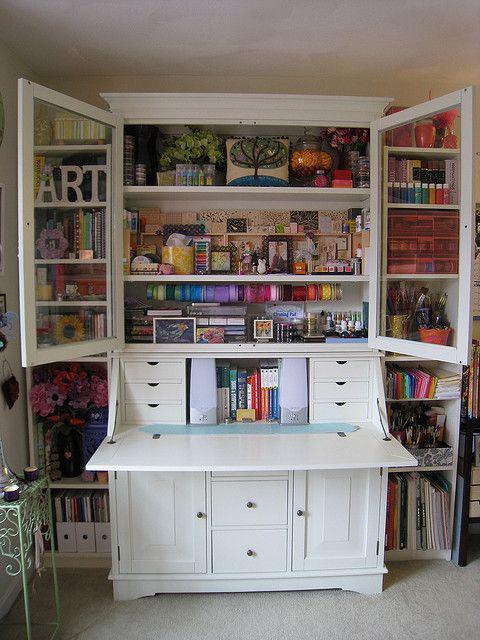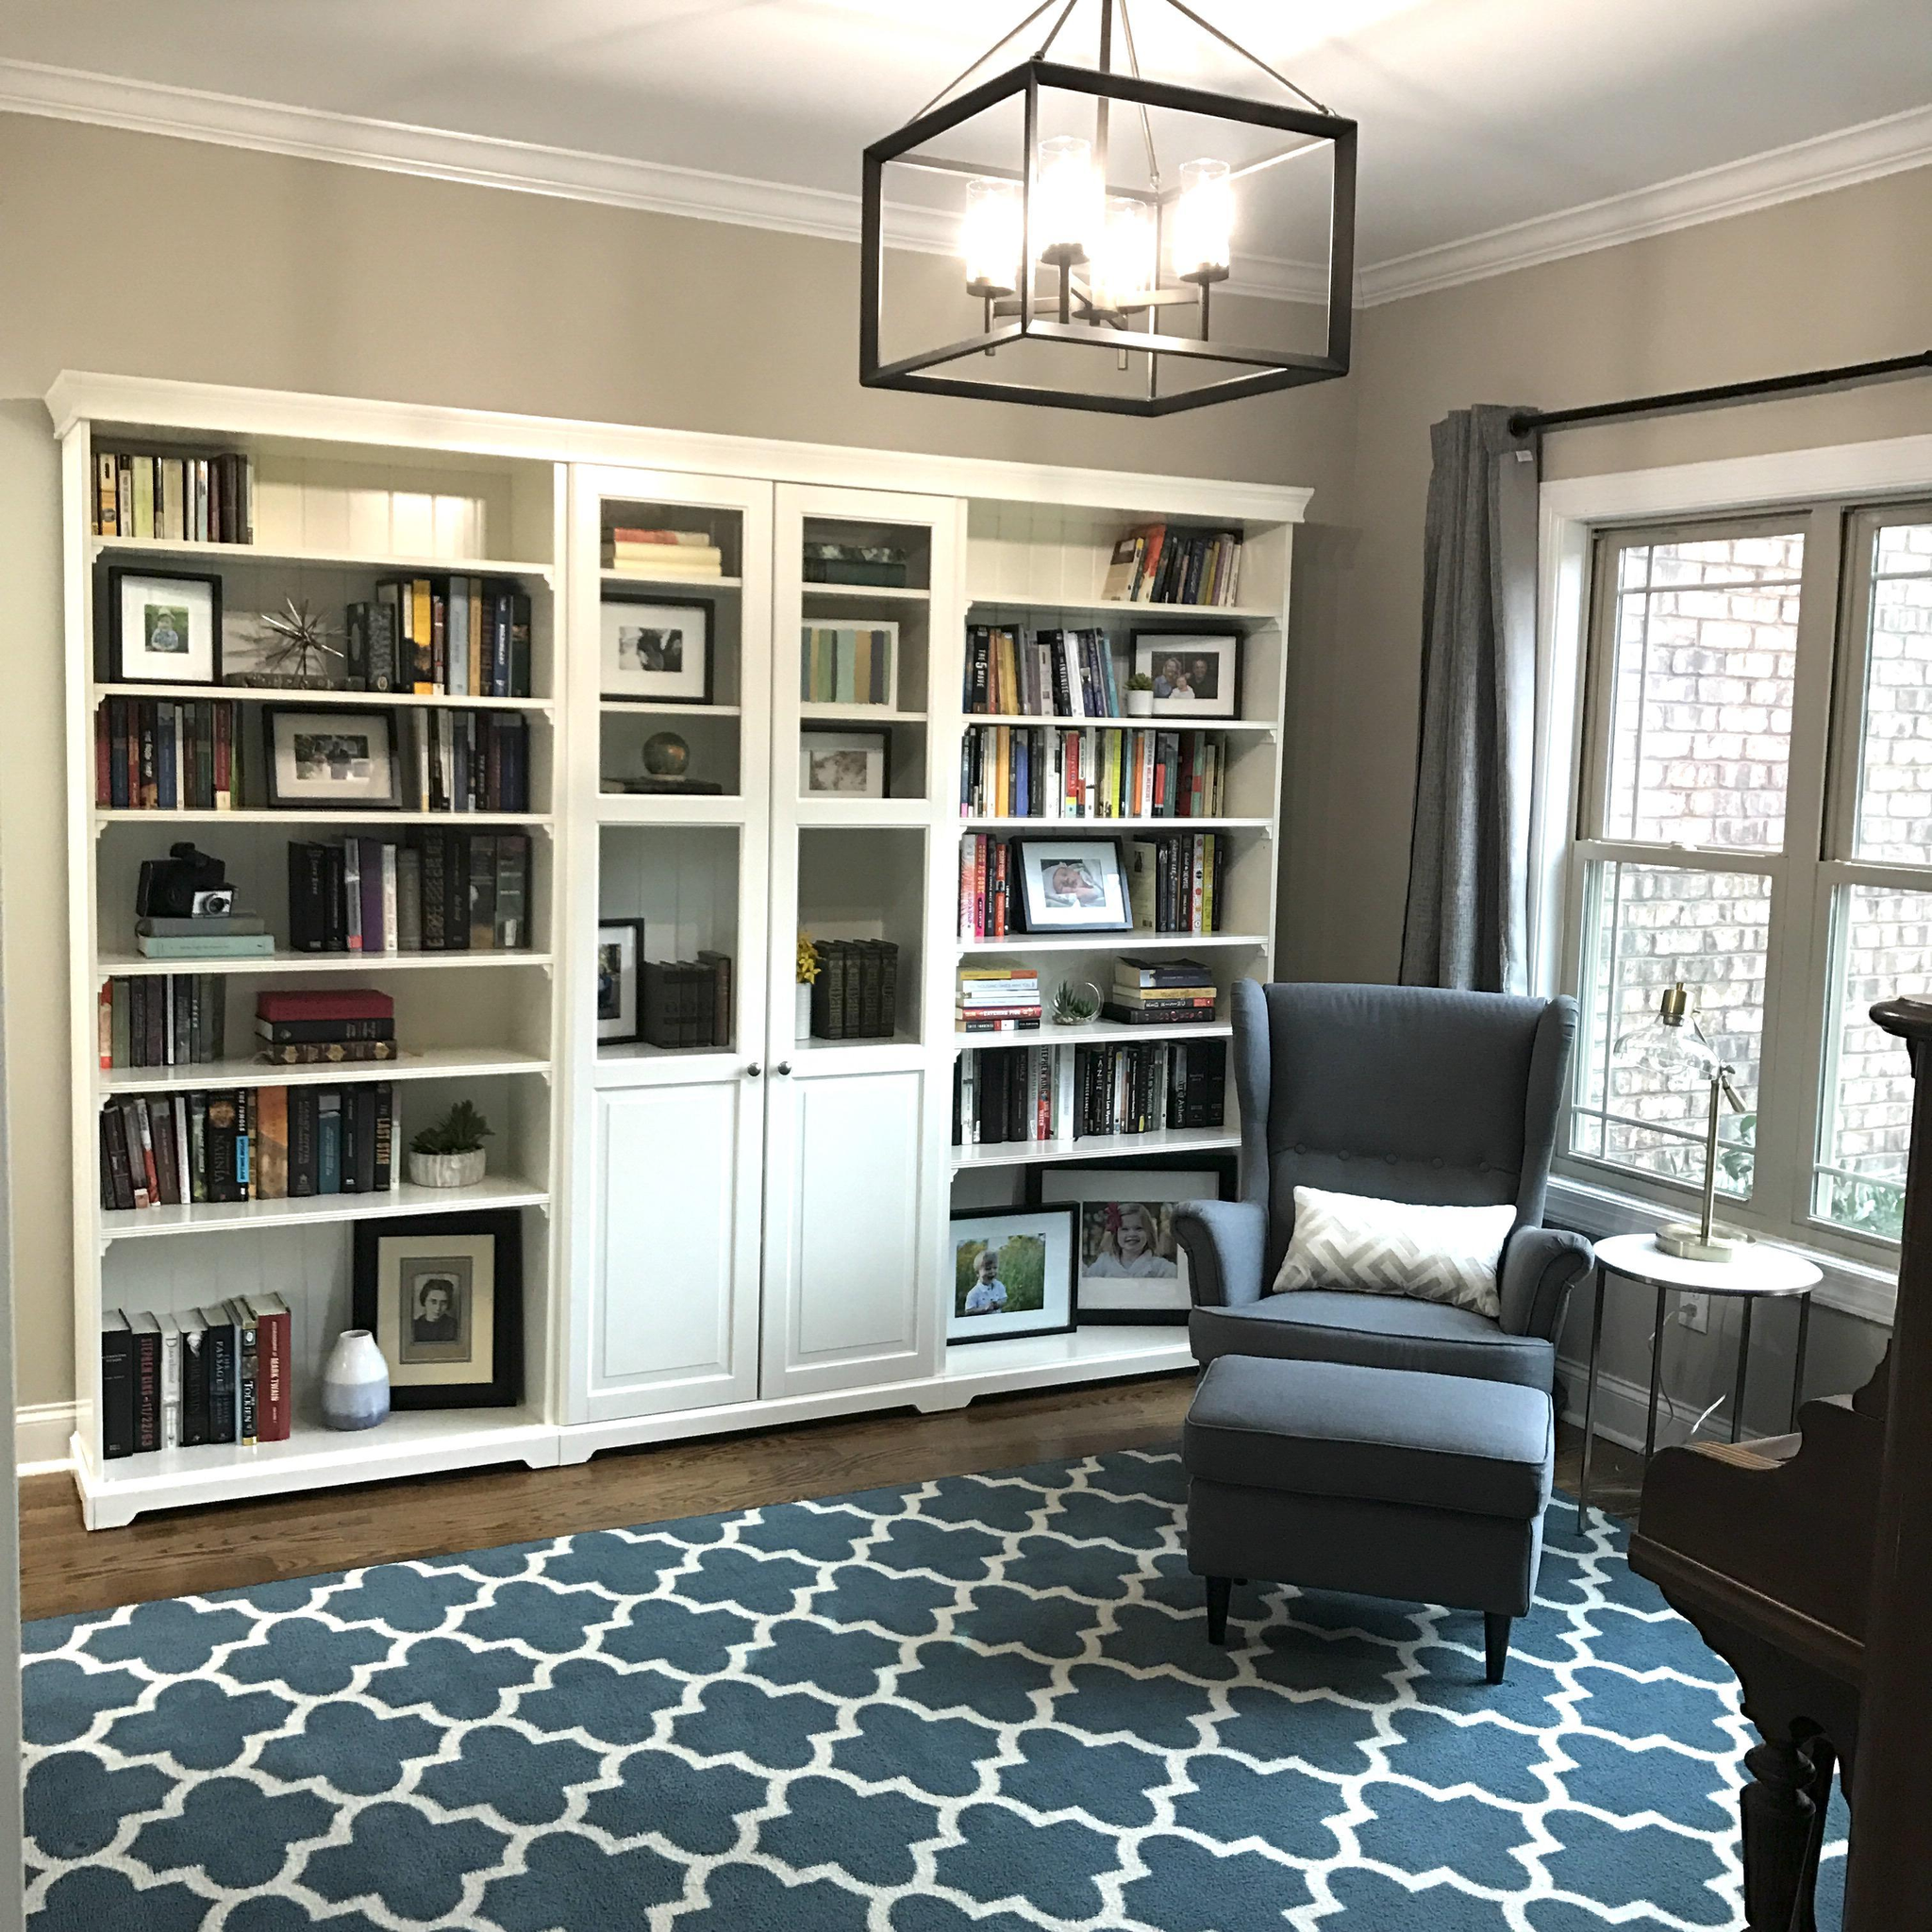The first image is the image on the left, the second image is the image on the right. Assess this claim about the two images: "There is a desk in each image.". Correct or not? Answer yes or no. No. The first image is the image on the left, the second image is the image on the right. Analyze the images presented: Is the assertion "One image features a traditional desk up against a wall, with a hutch on top of the desk, a one-door cabinet underneath on the left, and two drawers on the right." valid? Answer yes or no. No. 